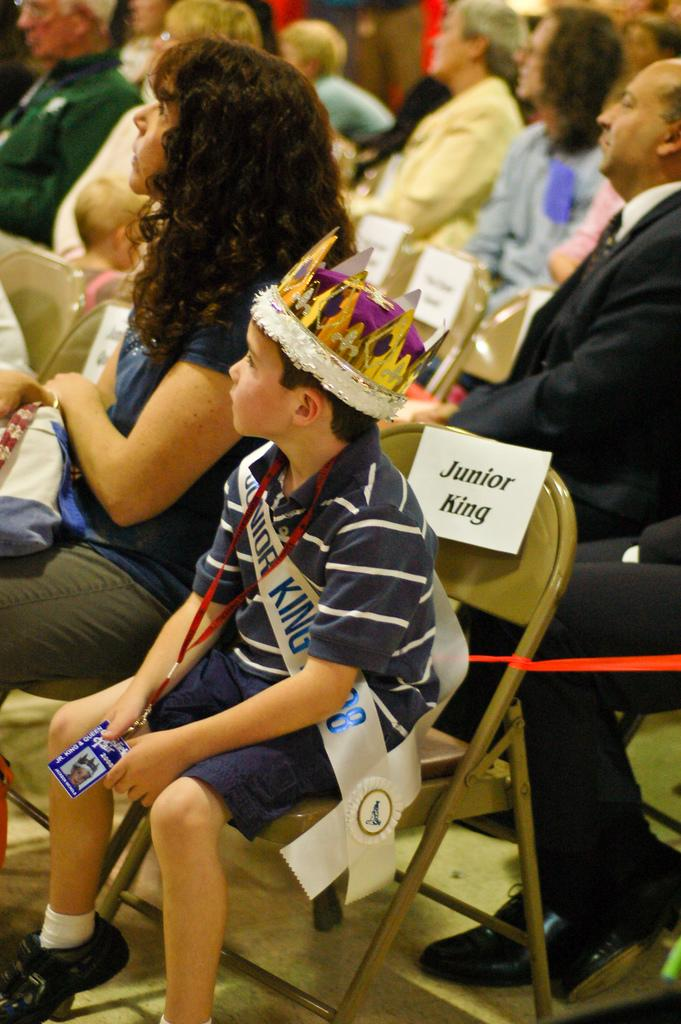What is happening in the image? There are people sitting in the image. Can you describe the boy's position in the image? The boy is sitting in the center of the image. What is the boy wearing on his head? The boy is wearing a crown. What type of planes are being discussed in the meeting in the image? There is no meeting or mention of planes in the image; it simply shows people sitting and a boy wearing a crown. 